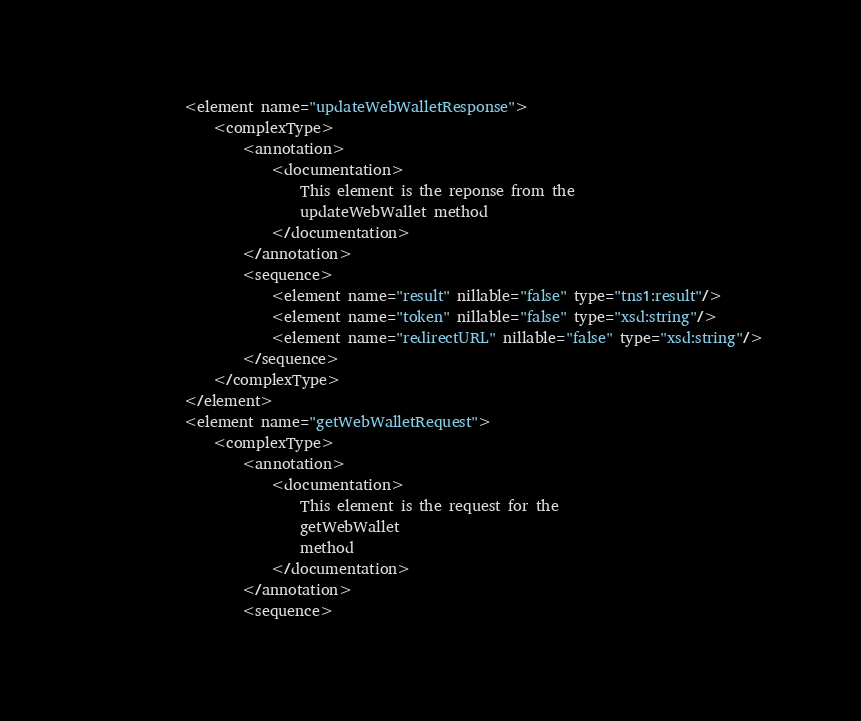Convert code to text. <code><loc_0><loc_0><loc_500><loc_500><_XML_>			<element name="updateWebWalletResponse">
				<complexType>
					<annotation>
						<documentation>
							This element is the reponse from the
							updateWebWallet method
						</documentation>
					</annotation>
					<sequence>
						<element name="result" nillable="false" type="tns1:result"/>
						<element name="token" nillable="false" type="xsd:string"/>
						<element name="redirectURL" nillable="false" type="xsd:string"/>
					</sequence>
				</complexType>
			</element>
			<element name="getWebWalletRequest">
				<complexType>
					<annotation>
						<documentation>
							This element is the request for the
							getWebWallet
							method
						</documentation>
					</annotation>
					<sequence></code> 